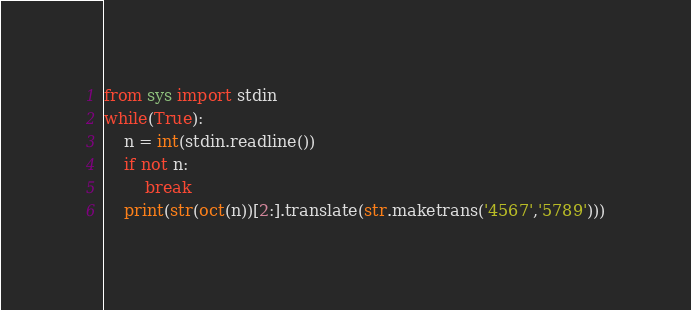Convert code to text. <code><loc_0><loc_0><loc_500><loc_500><_Python_>from sys import stdin
while(True):
    n = int(stdin.readline())
    if not n:
        break
    print(str(oct(n))[2:].translate(str.maketrans('4567','5789')))

</code> 